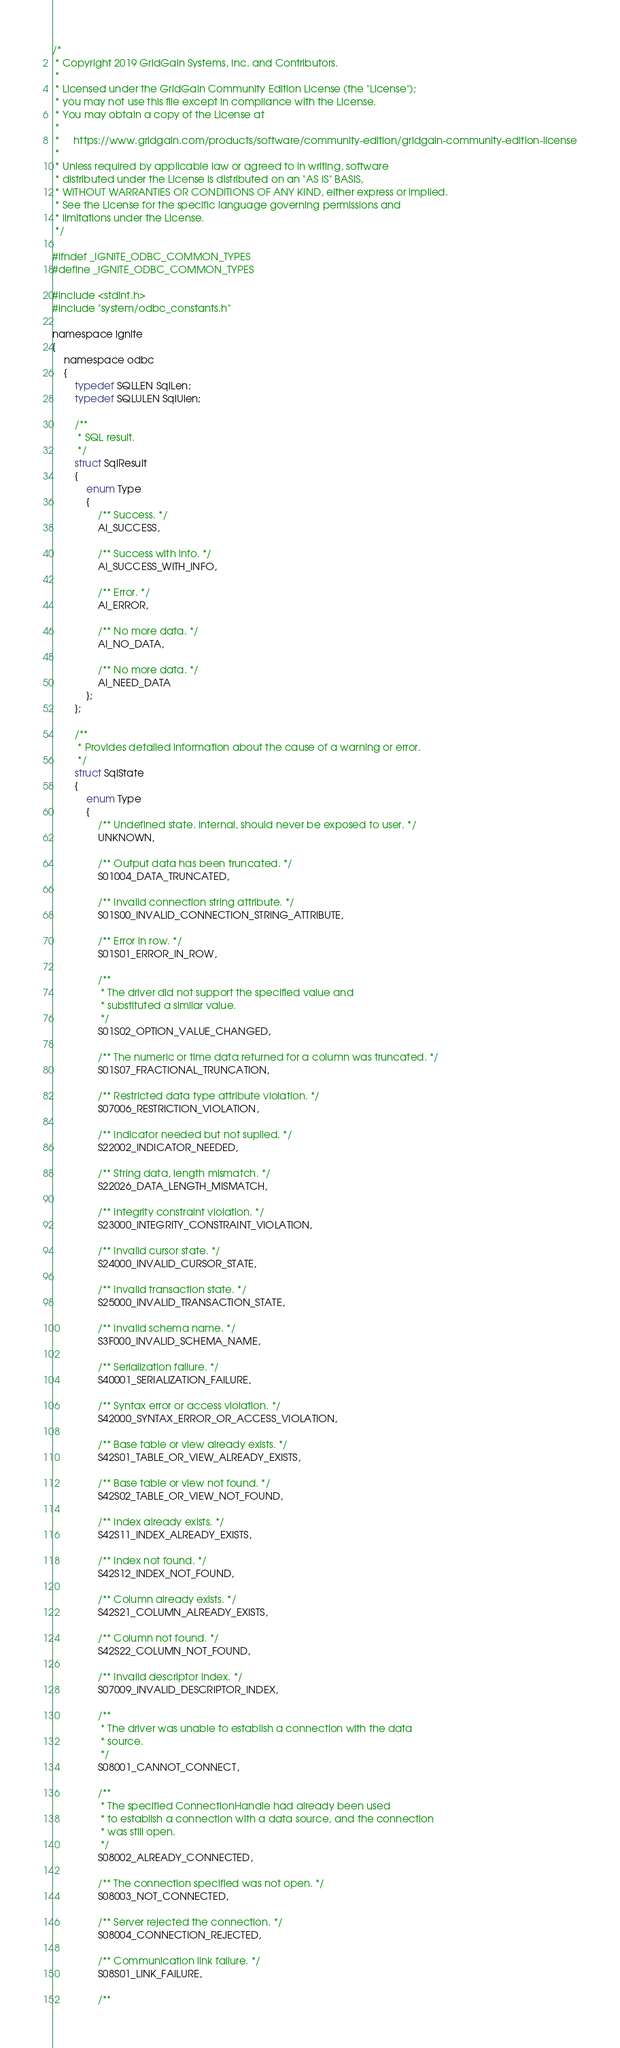Convert code to text. <code><loc_0><loc_0><loc_500><loc_500><_C_>/*
 * Copyright 2019 GridGain Systems, Inc. and Contributors.
 *
 * Licensed under the GridGain Community Edition License (the "License");
 * you may not use this file except in compliance with the License.
 * You may obtain a copy of the License at
 *
 *     https://www.gridgain.com/products/software/community-edition/gridgain-community-edition-license
 *
 * Unless required by applicable law or agreed to in writing, software
 * distributed under the License is distributed on an "AS IS" BASIS,
 * WITHOUT WARRANTIES OR CONDITIONS OF ANY KIND, either express or implied.
 * See the License for the specific language governing permissions and
 * limitations under the License.
 */

#ifndef _IGNITE_ODBC_COMMON_TYPES
#define _IGNITE_ODBC_COMMON_TYPES

#include <stdint.h>
#include "system/odbc_constants.h"

namespace ignite
{
    namespace odbc
    {
        typedef SQLLEN SqlLen;
        typedef SQLULEN SqlUlen;

        /**
         * SQL result.
         */
        struct SqlResult
        {
            enum Type
            {
                /** Success. */
                AI_SUCCESS,

                /** Success with info. */
                AI_SUCCESS_WITH_INFO,

                /** Error. */
                AI_ERROR,

                /** No more data. */
                AI_NO_DATA,

                /** No more data. */
                AI_NEED_DATA
            };
        };

        /**
         * Provides detailed information about the cause of a warning or error.
         */
        struct SqlState
        {
            enum Type
            {
                /** Undefined state. Internal, should never be exposed to user. */
                UNKNOWN,

                /** Output data has been truncated. */
                S01004_DATA_TRUNCATED,

                /** Invalid connection string attribute. */
                S01S00_INVALID_CONNECTION_STRING_ATTRIBUTE,

                /** Error in row. */
                S01S01_ERROR_IN_ROW,

                /**
                 * The driver did not support the specified value and
                 * substituted a similar value.
                 */
                S01S02_OPTION_VALUE_CHANGED,

                /** The numeric or time data returned for a column was truncated. */
                S01S07_FRACTIONAL_TRUNCATION,

                /** Restricted data type attribute violation. */
                S07006_RESTRICTION_VIOLATION,

                /** Indicator needed but not suplied. */
                S22002_INDICATOR_NEEDED,

                /** String data, length mismatch. */
                S22026_DATA_LENGTH_MISMATCH,

                /** Integrity constraint violation. */
                S23000_INTEGRITY_CONSTRAINT_VIOLATION,

                /** Invalid cursor state. */
                S24000_INVALID_CURSOR_STATE,

                /** Invalid transaction state. */
                S25000_INVALID_TRANSACTION_STATE,

                /** Invalid schema name. */
                S3F000_INVALID_SCHEMA_NAME,

                /** Serialization failure. */
                S40001_SERIALIZATION_FAILURE,

                /** Syntax error or access violation. */
                S42000_SYNTAX_ERROR_OR_ACCESS_VIOLATION,

                /** Base table or view already exists. */
                S42S01_TABLE_OR_VIEW_ALREADY_EXISTS,

                /** Base table or view not found. */
                S42S02_TABLE_OR_VIEW_NOT_FOUND,

                /** Index already exists. */
                S42S11_INDEX_ALREADY_EXISTS,

                /** Index not found. */
                S42S12_INDEX_NOT_FOUND,

                /** Column already exists. */
                S42S21_COLUMN_ALREADY_EXISTS,

                /** Column not found. */
                S42S22_COLUMN_NOT_FOUND,

                /** Invalid descriptor index. */
                S07009_INVALID_DESCRIPTOR_INDEX,

                /**
                 * The driver was unable to establish a connection with the data
                 * source.
                 */
                S08001_CANNOT_CONNECT,

                /**
                 * The specified ConnectionHandle had already been used
                 * to establish a connection with a data source, and the connection
                 * was still open.
                 */
                S08002_ALREADY_CONNECTED,

                /** The connection specified was not open. */
                S08003_NOT_CONNECTED,

                /** Server rejected the connection. */
                S08004_CONNECTION_REJECTED,

                /** Communication link failure. */
                S08S01_LINK_FAILURE,

                /**</code> 